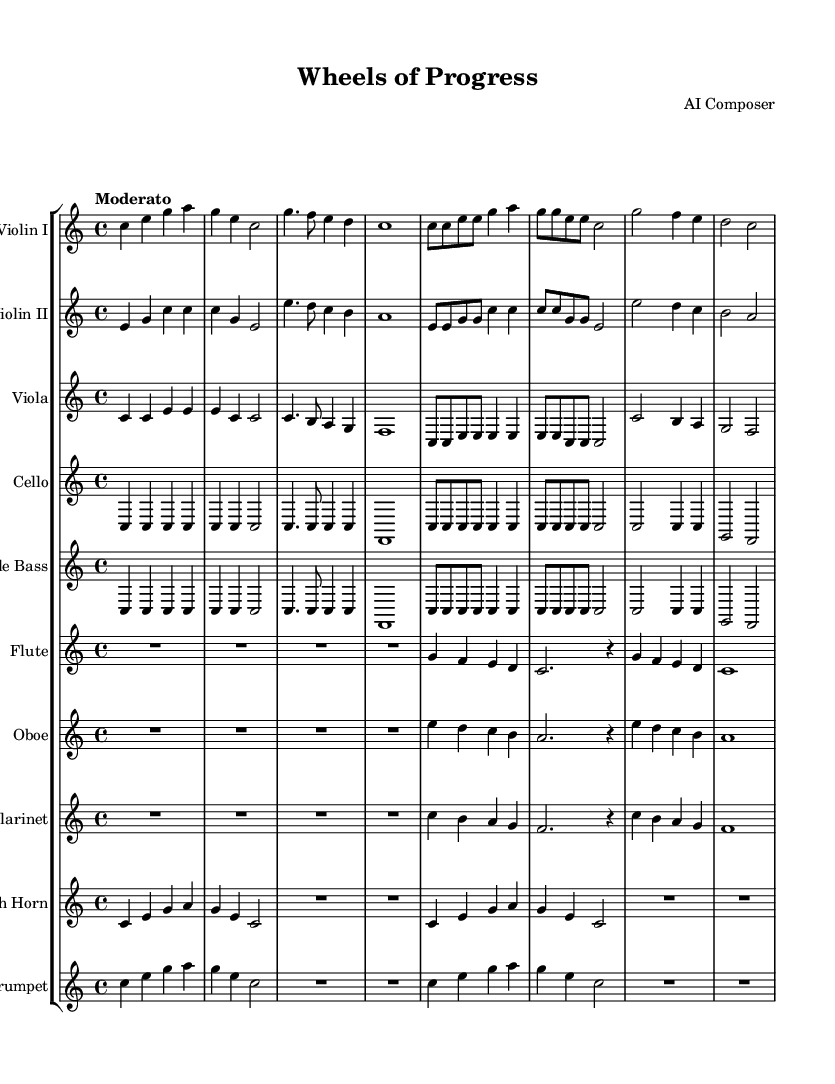What is the key signature of this music? The key signature indicated is C major, which contains no sharps or flats. This can be confirmed by the absence of any sharp or flat symbols at the beginning of the staff.
Answer: C major What is the time signature of this music? The time signature is indicated as 4/4, which is seen at the beginning of the score. This means there are four beats in each measure and a quarter note gets one beat.
Answer: 4/4 What is the tempo marking for this piece? The tempo marking is "Moderato," which is provided at the beginning of the score. This indicates a moderate speed for the music.
Answer: Moderato How many measures are there in the first violin part? By counting the number of measures in the violin I part, we see there are a total of seven distinct measures. Each measure is separated by vertical lines.
Answer: 7 Which instruments are included in this symphony? The score lists a total of ten instruments including the violin I, violin II, viola, cello, double bass, flute, oboe, clarinet, French horn, and trumpet.
Answer: 10 instruments In which measure does the flute play its solo? The flute plays its solo in the first measure, indicated by the notation "R1*4", which signifies a rest for four beats before it starts playing notes in the following measures.
Answer: Measure 1 What is the primary theme represented by the first violins? The thematic material for the first violins primarily involves a sequence of rising and falling notes, promoting a sense of forward movement which symbolizes progress in the automotive industry within the context of environmental responsibility.
Answer: Rising and falling notes 